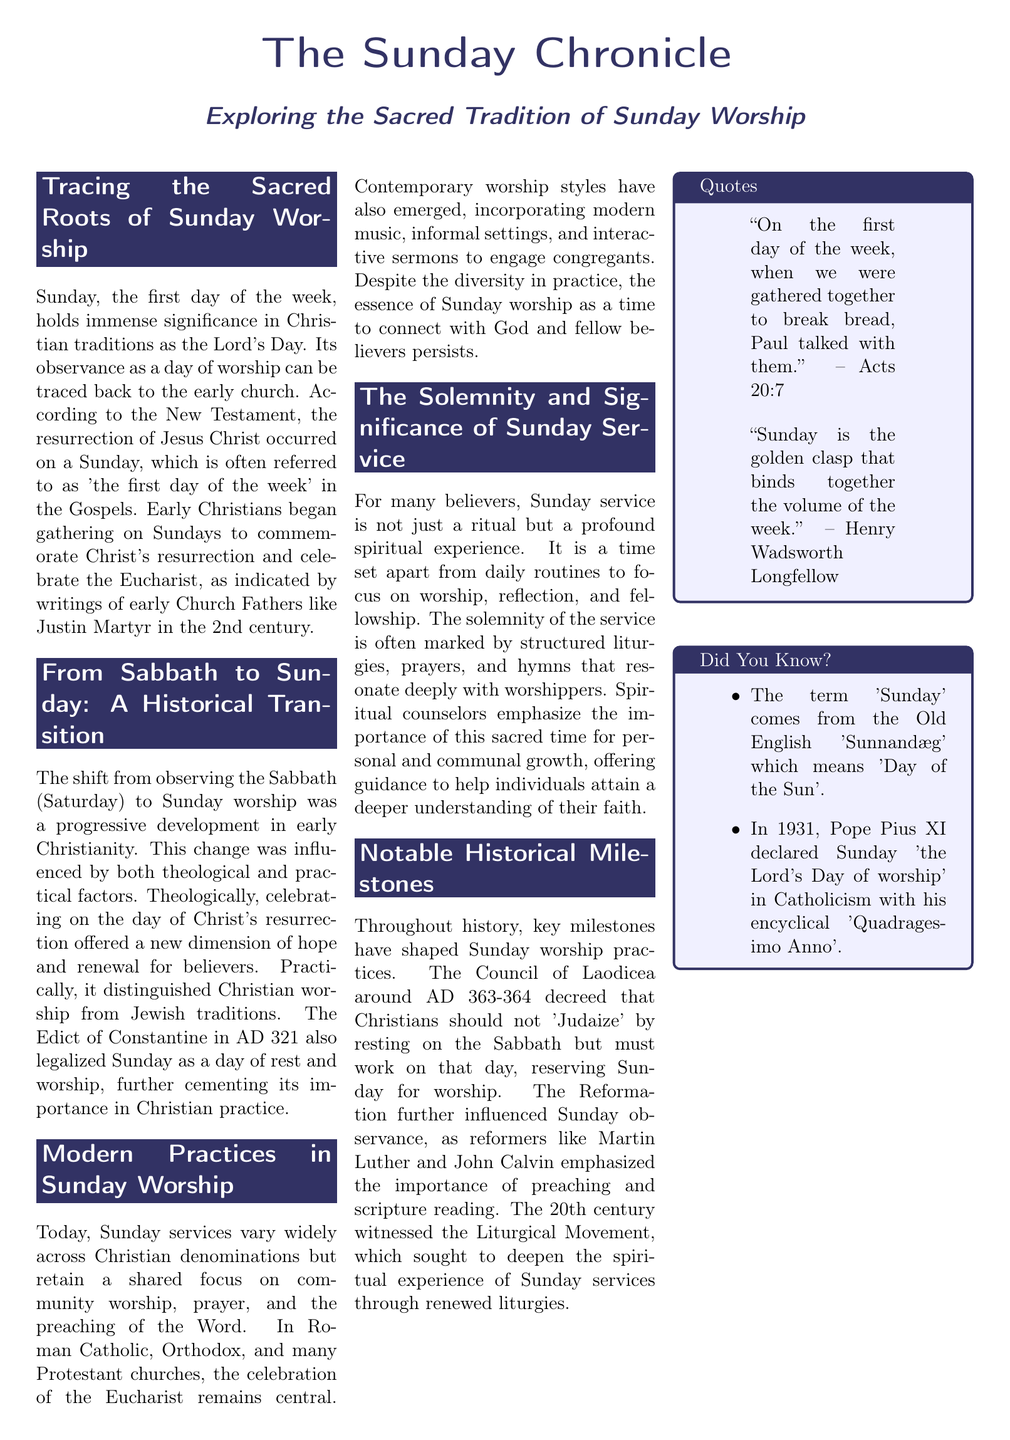What day of the week is observed as Sunday in Christian traditions? Sunday is specifically referred to as the first day of the week in Christian traditions.
Answer: First day Who was one of the early Church Fathers that mentioned Sunday worship? Justin Martyr is noted in the document for his writings on early Christian gatherings on Sundays.
Answer: Justin Martyr What significant event occurred on a Sunday according to the New Testament? The resurrection of Jesus Christ is cited as a crucial event that took place on Sunday.
Answer: Resurrection In what year did the Edict of Constantine legalize Sunday as a day of rest? The document notes that this edict was issued in AD 321.
Answer: AD 321 What is the primary focus of modern Sunday services across denominations? Community worship, prayer, and the preaching of the Word are highlighted as the main focus.
Answer: Community worship What does the Council of Laodicea decree about Sabbath observance? The decree stated that Christians should not 'Judaize' by resting on the Sabbath.
Answer: Should not 'Judaize' Which century did the Liturgical Movement occur that aimed to deepen spiritual experiences? The document indicates that the 20th century witnessed the Liturgical Movement.
Answer: 20th century What type of music has emerged in contemporary Sunday worship styles? The document mentions that modern music incorporates contemporary styles in services.
Answer: Modern music 